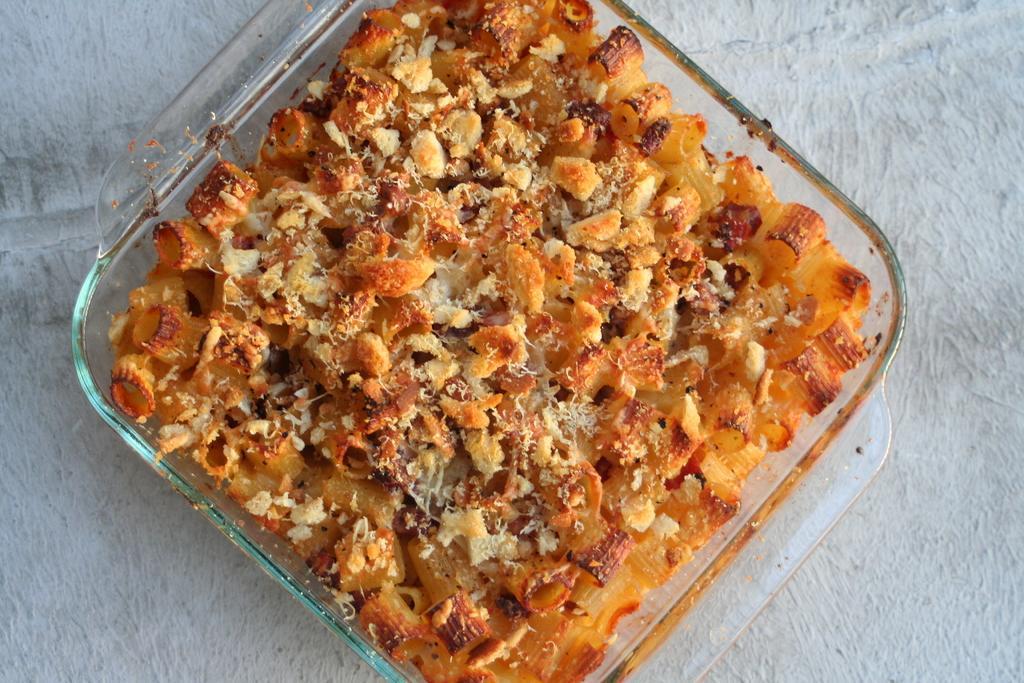How would you summarize this image in a sentence or two? In this image, we can see some food in the tiffin box and there is a white color background. 